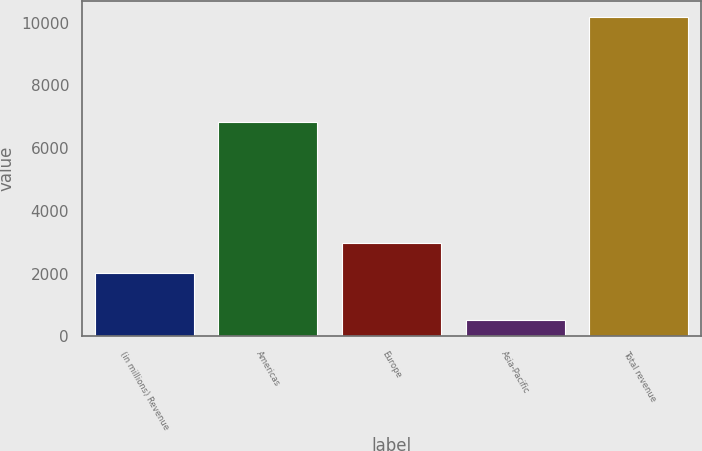Convert chart to OTSL. <chart><loc_0><loc_0><loc_500><loc_500><bar_chart><fcel>(in millions) Revenue<fcel>Americas<fcel>Europe<fcel>Asia-Pacific<fcel>Total revenue<nl><fcel>2013<fcel>6829<fcel>2979.1<fcel>519<fcel>10180<nl></chart> 